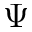<formula> <loc_0><loc_0><loc_500><loc_500>\Psi</formula> 